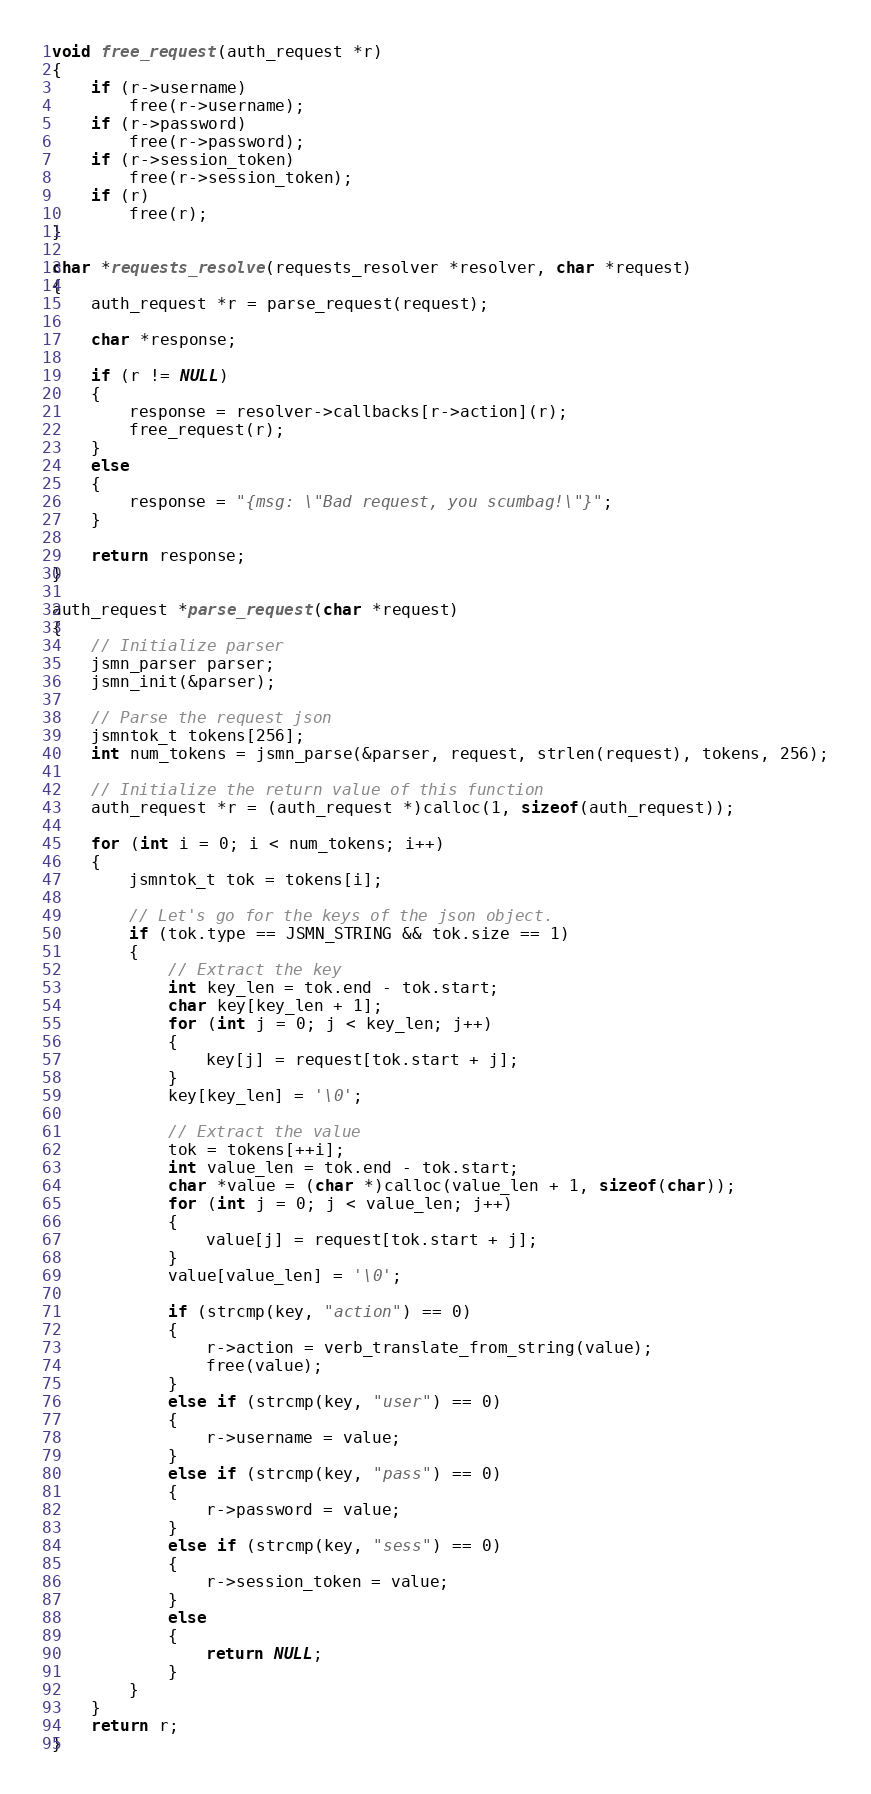Convert code to text. <code><loc_0><loc_0><loc_500><loc_500><_C_>void free_request(auth_request *r)
{
    if (r->username)
        free(r->username);
    if (r->password)
        free(r->password);
    if (r->session_token)
        free(r->session_token);
    if (r)
        free(r);
}

char *requests_resolve(requests_resolver *resolver, char *request)
{
    auth_request *r = parse_request(request);

    char *response;

    if (r != NULL)
    {
        response = resolver->callbacks[r->action](r);
        free_request(r);
    }
    else
    {
        response = "{msg: \"Bad request, you scumbag!\"}";
    }

    return response;
}

auth_request *parse_request(char *request)
{
    // Initialize parser
    jsmn_parser parser;
    jsmn_init(&parser);

    // Parse the request json
    jsmntok_t tokens[256];
    int num_tokens = jsmn_parse(&parser, request, strlen(request), tokens, 256);

    // Initialize the return value of this function
    auth_request *r = (auth_request *)calloc(1, sizeof(auth_request));

    for (int i = 0; i < num_tokens; i++)
    {
        jsmntok_t tok = tokens[i];

        // Let's go for the keys of the json object.
        if (tok.type == JSMN_STRING && tok.size == 1)
        {
            // Extract the key
            int key_len = tok.end - tok.start;
            char key[key_len + 1];
            for (int j = 0; j < key_len; j++)
            {
                key[j] = request[tok.start + j];
            }
            key[key_len] = '\0';

            // Extract the value
            tok = tokens[++i];
            int value_len = tok.end - tok.start;
            char *value = (char *)calloc(value_len + 1, sizeof(char));
            for (int j = 0; j < value_len; j++)
            {
                value[j] = request[tok.start + j];
            }
            value[value_len] = '\0';

            if (strcmp(key, "action") == 0)
            {
                r->action = verb_translate_from_string(value);
                free(value);
            }
            else if (strcmp(key, "user") == 0)
            {
                r->username = value;
            }
            else if (strcmp(key, "pass") == 0)
            {
                r->password = value;
            }
            else if (strcmp(key, "sess") == 0)
            {
                r->session_token = value;
            }
            else
            {
                return NULL;
            }
        }
    }
    return r;
}
</code> 